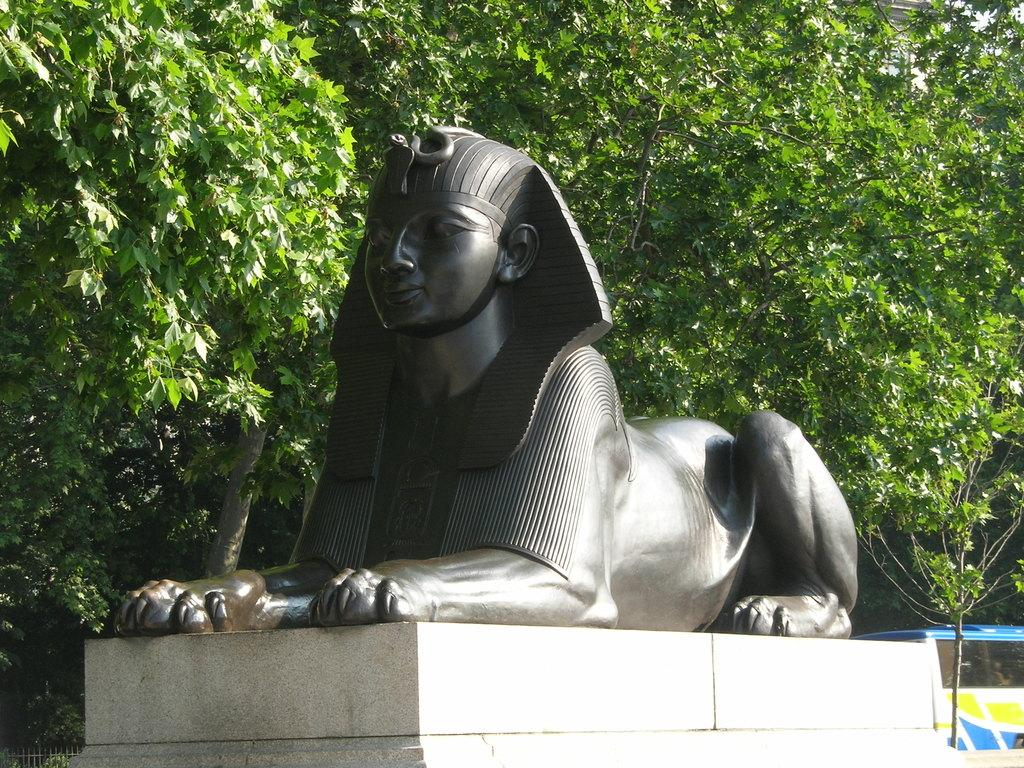What type of sculpture is in the image? There is a stone sculpture in the image. What features can be identified on the sculpture? The sculpture has a lion body and an Egypt mummy face. What can be seen in the background of the image? There are plants in the background of the image. How many mouths does the lion sculpture have in the image? The sculpture does not have a mouth, as it is a stone sculpture with a lion body and an Egypt mummy face. 